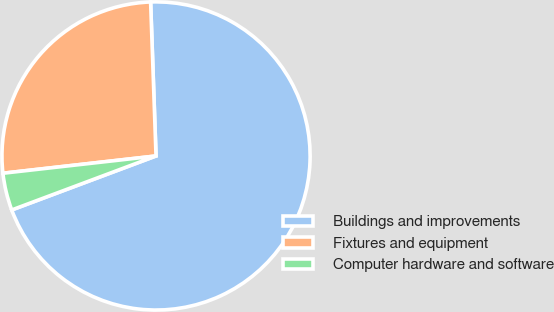Convert chart to OTSL. <chart><loc_0><loc_0><loc_500><loc_500><pie_chart><fcel>Buildings and improvements<fcel>Fixtures and equipment<fcel>Computer hardware and software<nl><fcel>69.86%<fcel>26.23%<fcel>3.91%<nl></chart> 